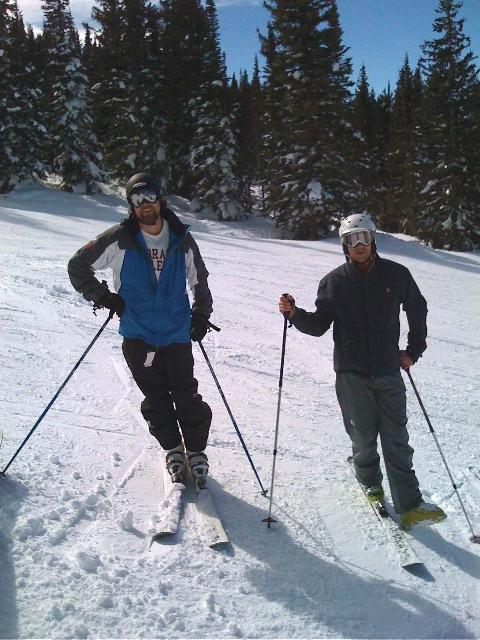How many people are holding ski poles?

Choices:
A) four
B) six
C) two
D) five two 